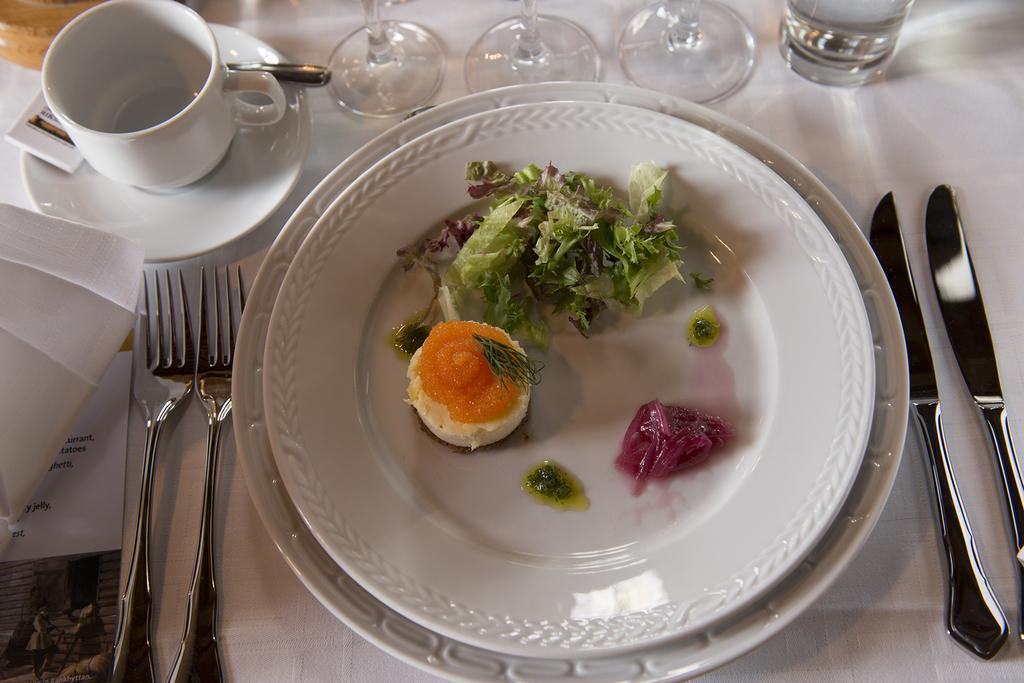What is on the plate in the image? There are food items served on a plate in the image. What utensils are present in the image? There are knives and forks in the image. What type of container is present for holding liquids? There is a cup in the image. What is the saucer used for in the image? The saucer is present in the image, likely to hold the cup. What type of glassware is visible in the image? There are glasses in the image. What type of leather material is used to make the history book in the image? There is no history book or leather material present in the image. 